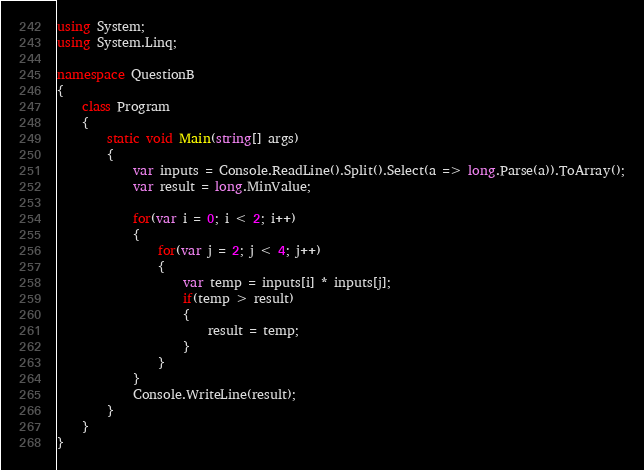Convert code to text. <code><loc_0><loc_0><loc_500><loc_500><_C#_>using System;
using System.Linq;

namespace QuestionB
{
    class Program
    {
        static void Main(string[] args)
        {
            var inputs = Console.ReadLine().Split().Select(a => long.Parse(a)).ToArray();
            var result = long.MinValue;
            
            for(var i = 0; i < 2; i++)
            {
                for(var j = 2; j < 4; j++)
                {
                    var temp = inputs[i] * inputs[j];
                    if(temp > result)
                    {
                        result = temp;
                    }
                }
            }
            Console.WriteLine(result);
        }
    }
}
</code> 